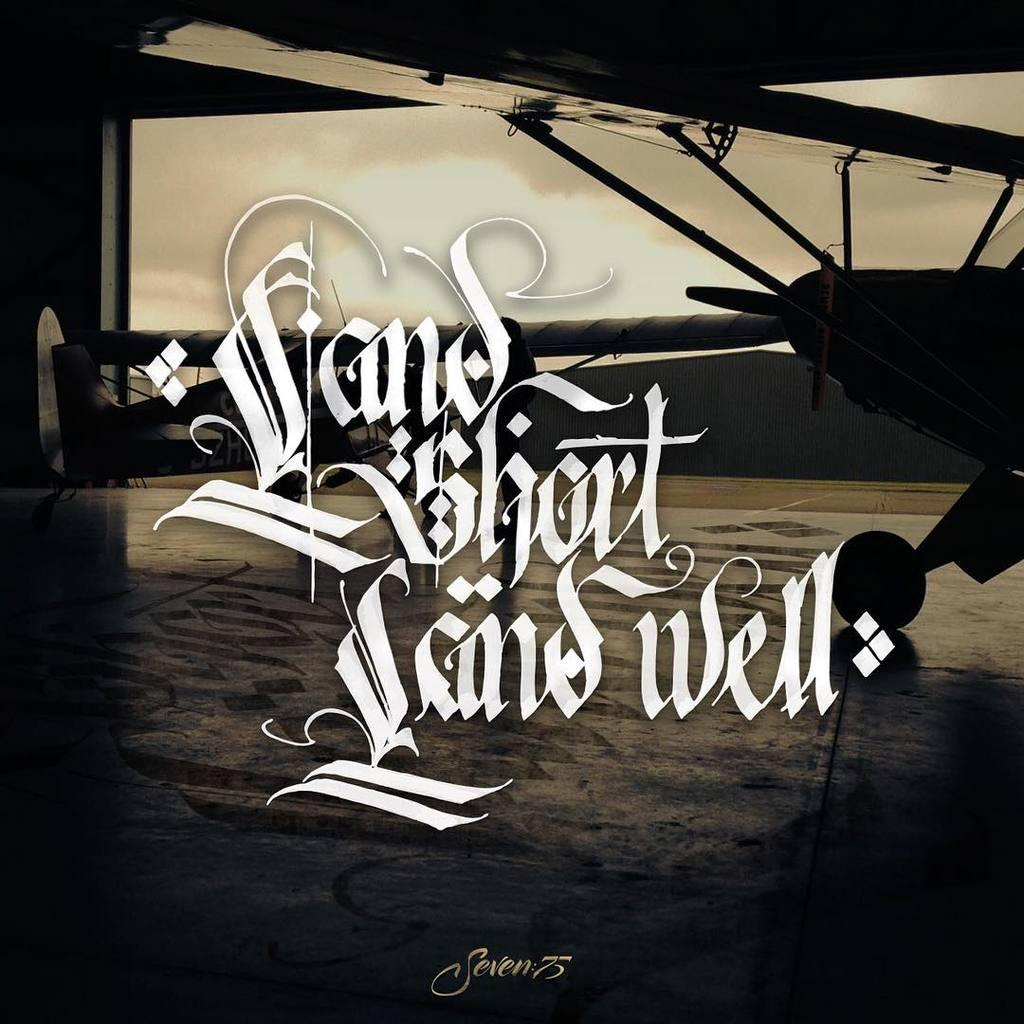What is the main subject of the image? The main subject of the image is a plane. Can you describe any text present in the image? Yes, there is white color text in the image. What type of question is the doll asking in the image? There is no doll present in the image, and therefore no doll can be asking any questions. 